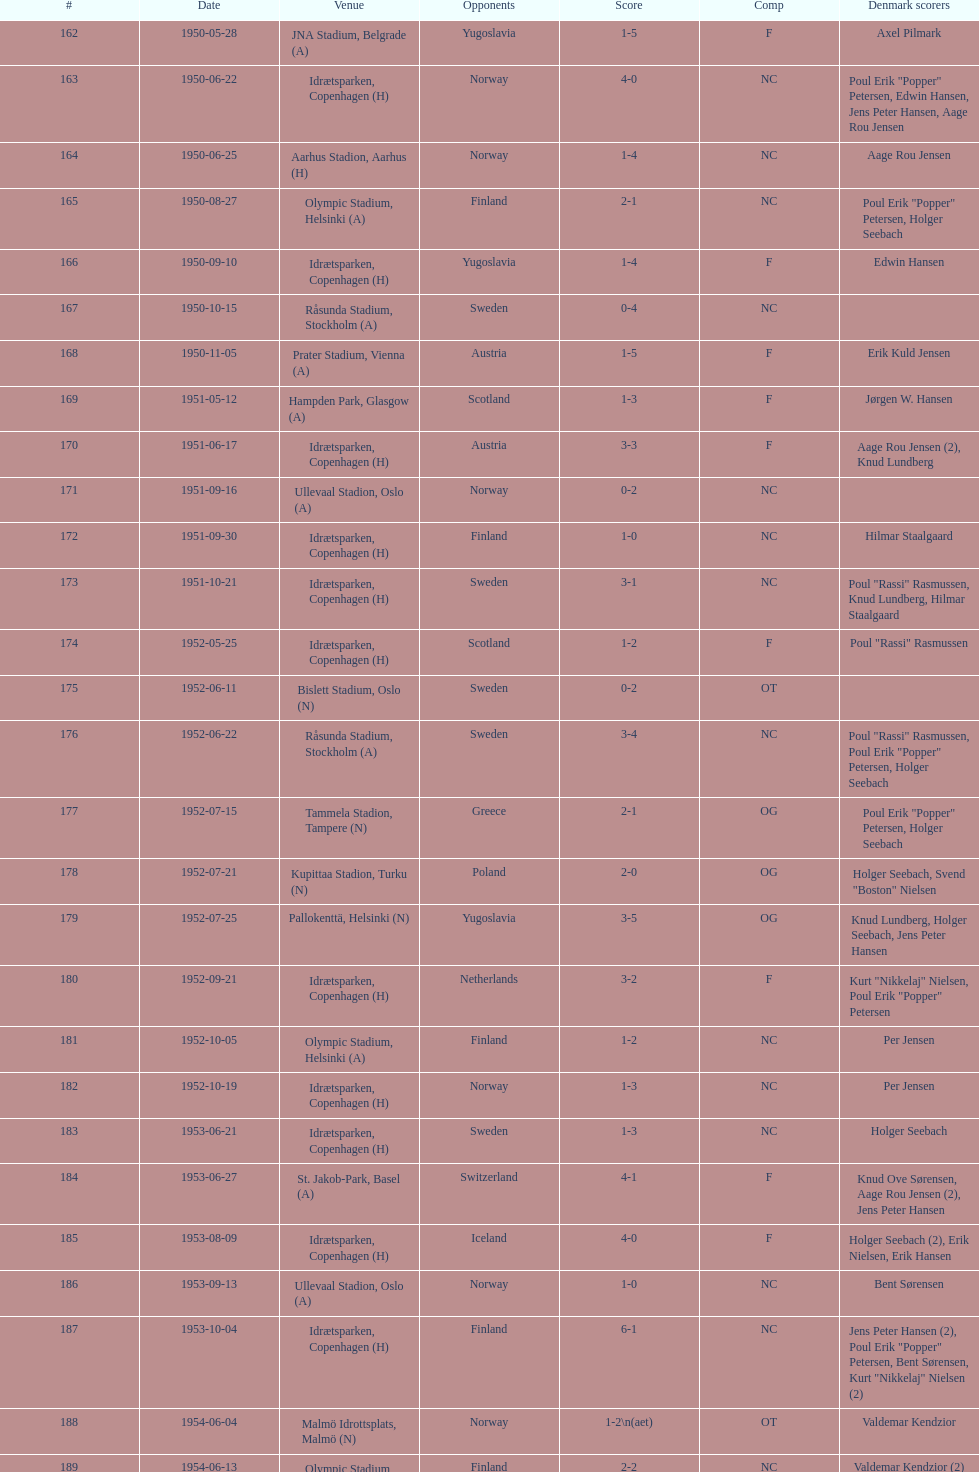When was the last time the team went 0-6? 1959-06-21. 